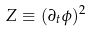<formula> <loc_0><loc_0><loc_500><loc_500>Z \equiv ( \partial _ { t } \phi ) ^ { 2 }</formula> 